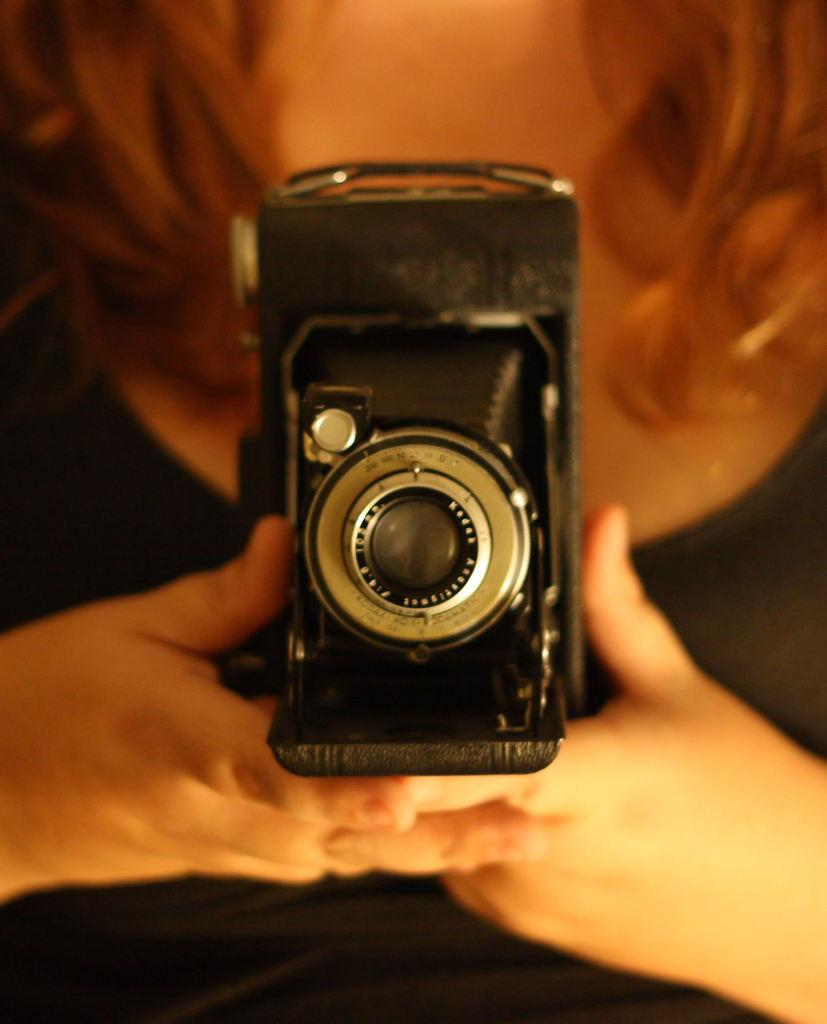What is the main subject of the image? The main subject of the image is a woman. What is the woman wearing in the image? The woman is wearing a black dress. What object is the woman holding in the image? The woman is holding a black color camera. What type of chalk can be seen in the woman's hand in the image? There is no chalk present in the image; the woman is holding a black color camera. What knowledge does the woman possess about the door in the image? There is no door present in the image, so it is not possible to determine any knowledge the woman might possess about a door. 